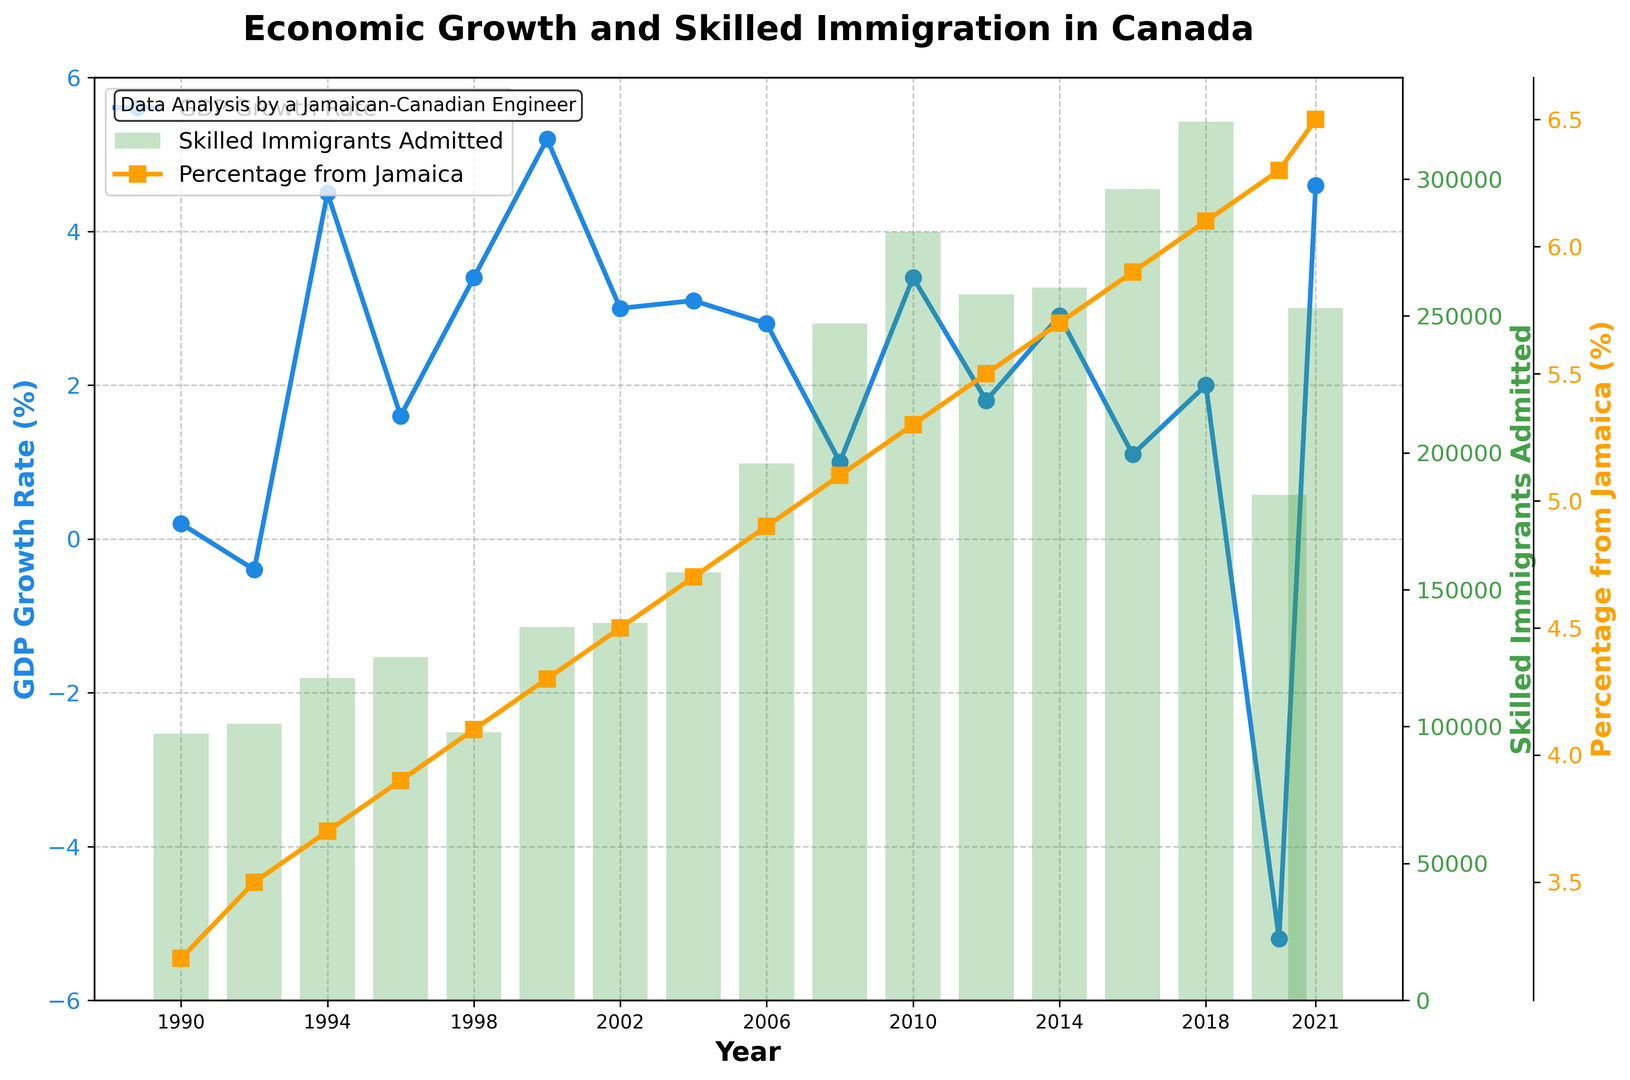what was the GDP growth rate and the percentage of skilled immigrants from Jamaica in 2000? To find this, look at the GDP growth rate line for the year 2000 and the percentage of skilled immigrants from Jamaica line for the same year.
Answer: 5.2%, 4.3% compare the number of skilled immigrants admitted in 2010 versus 2020. Which year had a higher number? Refer to the height of the bars corresponding to the years 2010 and 2020 and compare them. The bar for 2010 is higher than the one for 2020.
Answer: 2010 what is the trend of the GDP growth rate from 2018 to 2020? Observe the GDP growth rate line from 2018 to 2020. The line declines steeply, indicating a negative GDP growth rate trend.
Answer: Downward what is the combined average percentage of skilled immigrants from Jamaica for the years 1990, 2000, and 2010? Add the percentages for the years mentioned and divide by the number of years. (3.2 + 4.3 + 5.3) / 3 = 4.27%
Answer: 4.27% Which year had the highest GDP growth rate and what was the skilled immigrants admitted in that year? Check the peak of the GDP growth rate line. The highest point is in 2000. Now look at the bar for skilled immigrants admitted in the same year.
Answer: 2000, 136292 Has the percentage of skilled immigrants from Jamaica consistently increased over time? Follow the percentage of skilled immigrants from Jamaica line from the beginning to the end of the period. The line shows a consistent upward trend.
Answer: Yes 